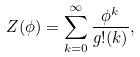Convert formula to latex. <formula><loc_0><loc_0><loc_500><loc_500>Z ( \phi ) = \sum _ { k = 0 } ^ { \infty } \frac { \phi ^ { k } } { g ! ( k ) } ,</formula> 